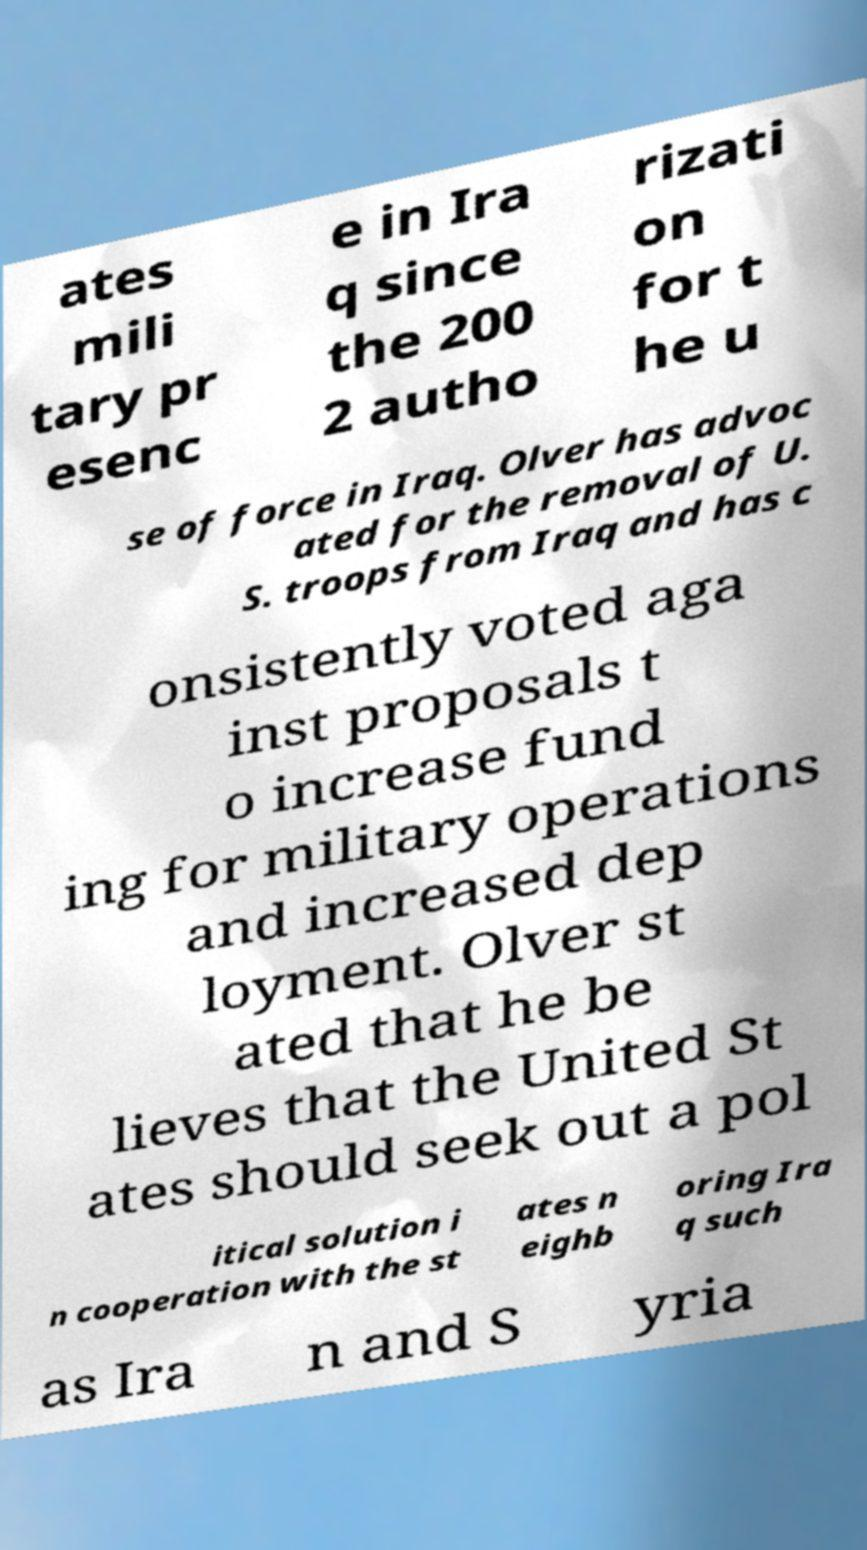Can you read and provide the text displayed in the image?This photo seems to have some interesting text. Can you extract and type it out for me? ates mili tary pr esenc e in Ira q since the 200 2 autho rizati on for t he u se of force in Iraq. Olver has advoc ated for the removal of U. S. troops from Iraq and has c onsistently voted aga inst proposals t o increase fund ing for military operations and increased dep loyment. Olver st ated that he be lieves that the United St ates should seek out a pol itical solution i n cooperation with the st ates n eighb oring Ira q such as Ira n and S yria 